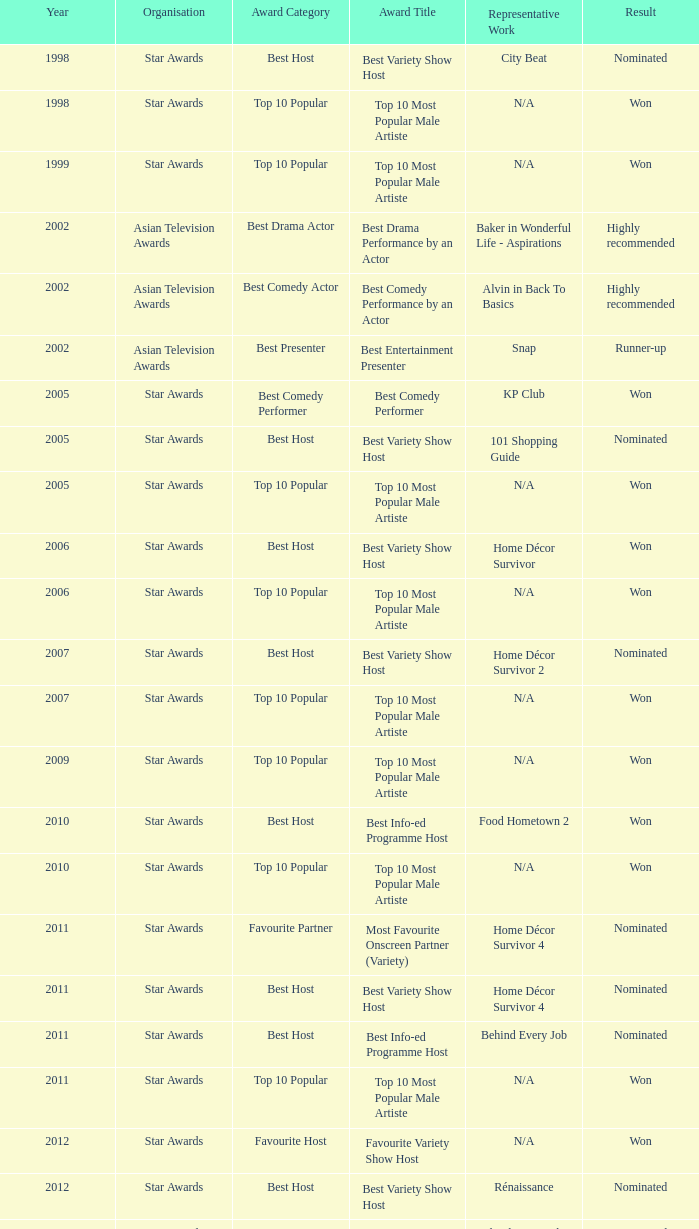What is the award for the Star Awards earlier than 2005 and the result is won? Top 10 Most Popular Male Artiste, Top 10 Most Popular Male Artiste. Could you parse the entire table? {'header': ['Year', 'Organisation', 'Award Category', 'Award Title', 'Representative Work', 'Result'], 'rows': [['1998', 'Star Awards', 'Best Host', 'Best Variety Show Host', 'City Beat', 'Nominated'], ['1998', 'Star Awards', 'Top 10 Popular', 'Top 10 Most Popular Male Artiste', 'N/A', 'Won'], ['1999', 'Star Awards', 'Top 10 Popular', 'Top 10 Most Popular Male Artiste', 'N/A', 'Won'], ['2002', 'Asian Television Awards', 'Best Drama Actor', 'Best Drama Performance by an Actor', 'Baker in Wonderful Life - Aspirations', 'Highly recommended'], ['2002', 'Asian Television Awards', 'Best Comedy Actor', 'Best Comedy Performance by an Actor', 'Alvin in Back To Basics', 'Highly recommended'], ['2002', 'Asian Television Awards', 'Best Presenter', 'Best Entertainment Presenter', 'Snap', 'Runner-up'], ['2005', 'Star Awards', 'Best Comedy Performer', 'Best Comedy Performer', 'KP Club', 'Won'], ['2005', 'Star Awards', 'Best Host', 'Best Variety Show Host', '101 Shopping Guide', 'Nominated'], ['2005', 'Star Awards', 'Top 10 Popular', 'Top 10 Most Popular Male Artiste', 'N/A', 'Won'], ['2006', 'Star Awards', 'Best Host', 'Best Variety Show Host', 'Home Décor Survivor', 'Won'], ['2006', 'Star Awards', 'Top 10 Popular', 'Top 10 Most Popular Male Artiste', 'N/A', 'Won'], ['2007', 'Star Awards', 'Best Host', 'Best Variety Show Host', 'Home Décor Survivor 2', 'Nominated'], ['2007', 'Star Awards', 'Top 10 Popular', 'Top 10 Most Popular Male Artiste', 'N/A', 'Won'], ['2009', 'Star Awards', 'Top 10 Popular', 'Top 10 Most Popular Male Artiste', 'N/A', 'Won'], ['2010', 'Star Awards', 'Best Host', 'Best Info-ed Programme Host', 'Food Hometown 2', 'Won'], ['2010', 'Star Awards', 'Top 10 Popular', 'Top 10 Most Popular Male Artiste', 'N/A', 'Won'], ['2011', 'Star Awards', 'Favourite Partner', 'Most Favourite Onscreen Partner (Variety)', 'Home Décor Survivor 4', 'Nominated'], ['2011', 'Star Awards', 'Best Host', 'Best Variety Show Host', 'Home Décor Survivor 4', 'Nominated'], ['2011', 'Star Awards', 'Best Host', 'Best Info-ed Programme Host', 'Behind Every Job', 'Nominated'], ['2011', 'Star Awards', 'Top 10 Popular', 'Top 10 Most Popular Male Artiste', 'N/A', 'Won'], ['2012', 'Star Awards', 'Favourite Host', 'Favourite Variety Show Host', 'N/A', 'Won'], ['2012', 'Star Awards', 'Best Host', 'Best Variety Show Host', 'Rénaissance', 'Nominated'], ['2012', 'Star Awards', 'Best Host', 'Best Info-ed Programme Host', 'Behind Every Job 2', 'Nominated'], ['2012', 'Star Awards', 'Top 10 Popular', 'Top 10 Most Popular Male Artiste', 'N/A', 'Won'], ['2013', 'Star Awards', 'Favourite Host', 'Favourite Variety Show Host', 'S.N.A.P. 熠熠星光总动员', 'Won'], ['2013', 'Star Awards', 'Top 10 Popular', 'Top 10 Most Popular Male Artiste', 'N/A', 'Won'], ['2013', 'Star Awards', 'Best Host', 'Best Info-Ed Programme Host', 'Makan Unlimited', 'Nominated'], ['2013', 'Star Awards', 'Best Host', 'Best Variety Show Host', 'Jobs Around The World', 'Nominated']]} 